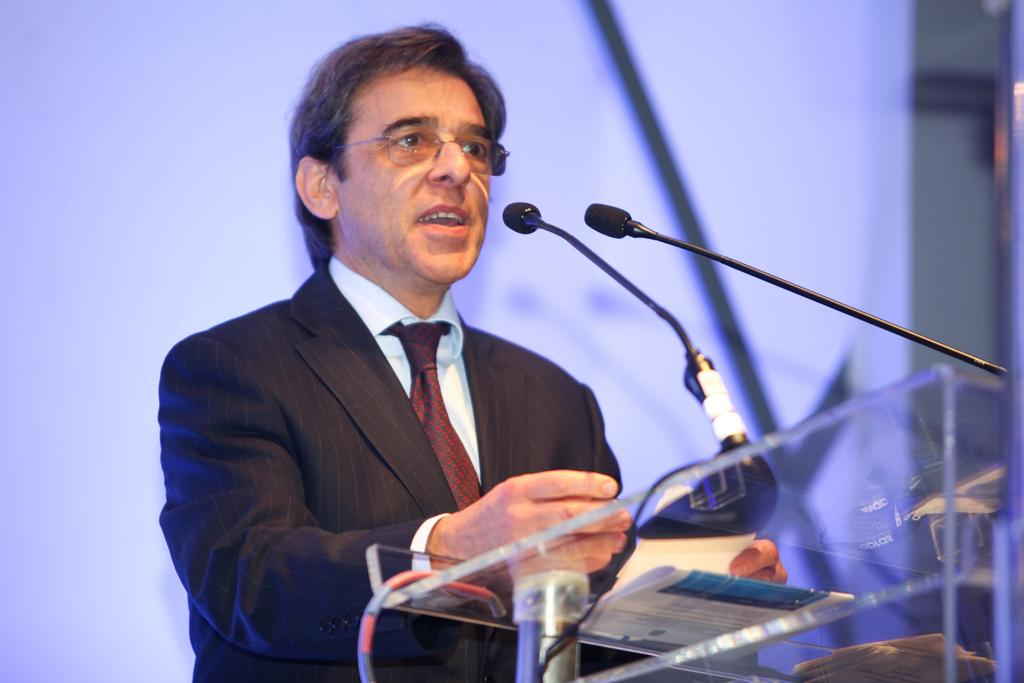What is the main subject of the image? The main subject of the image is a man. Can you describe the man's attire? The man is wearing spectacles, a blazer, a white shirt, and a tie. What is the man doing in the image? The man is standing near a podium. What can be seen on the podium? There are mice and a paper on the podium. How much credit does the man have on his tie in the image? There is no mention of credit or any financial aspect in the image. The man's tie is simply a part of his attire. What type of light is being used to illuminate the mice on the podium? The image does not provide any information about the lighting or illumination of the mice on the podium. 